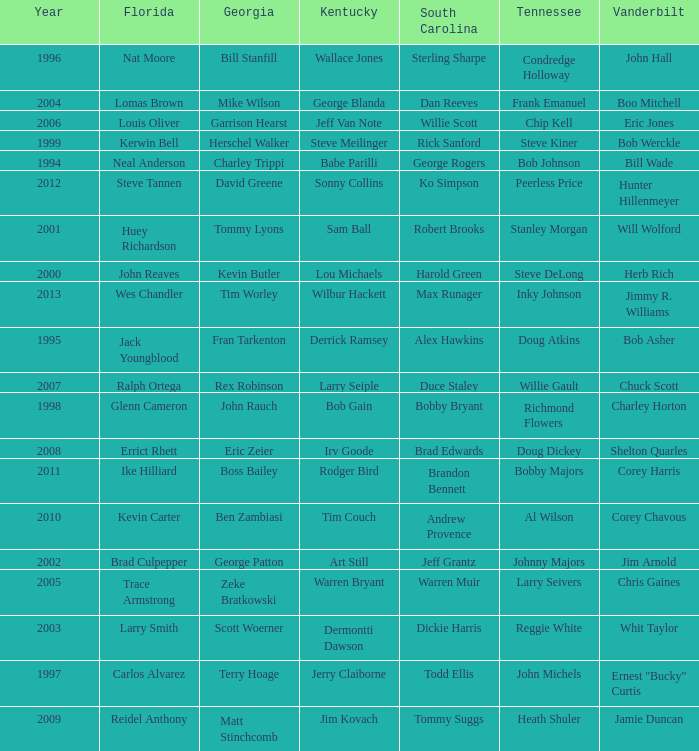What is the Tennessee with a Kentucky of Larry Seiple Willie Gault. 